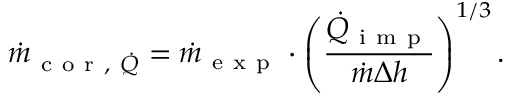Convert formula to latex. <formula><loc_0><loc_0><loc_500><loc_500>\dot { m } _ { c o r , \dot { Q } } = \dot { m } _ { e x p } \cdot \left ( \frac { \dot { Q } _ { i m p } } { \dot { m } \Delta h } \right ) ^ { 1 / 3 } .</formula> 